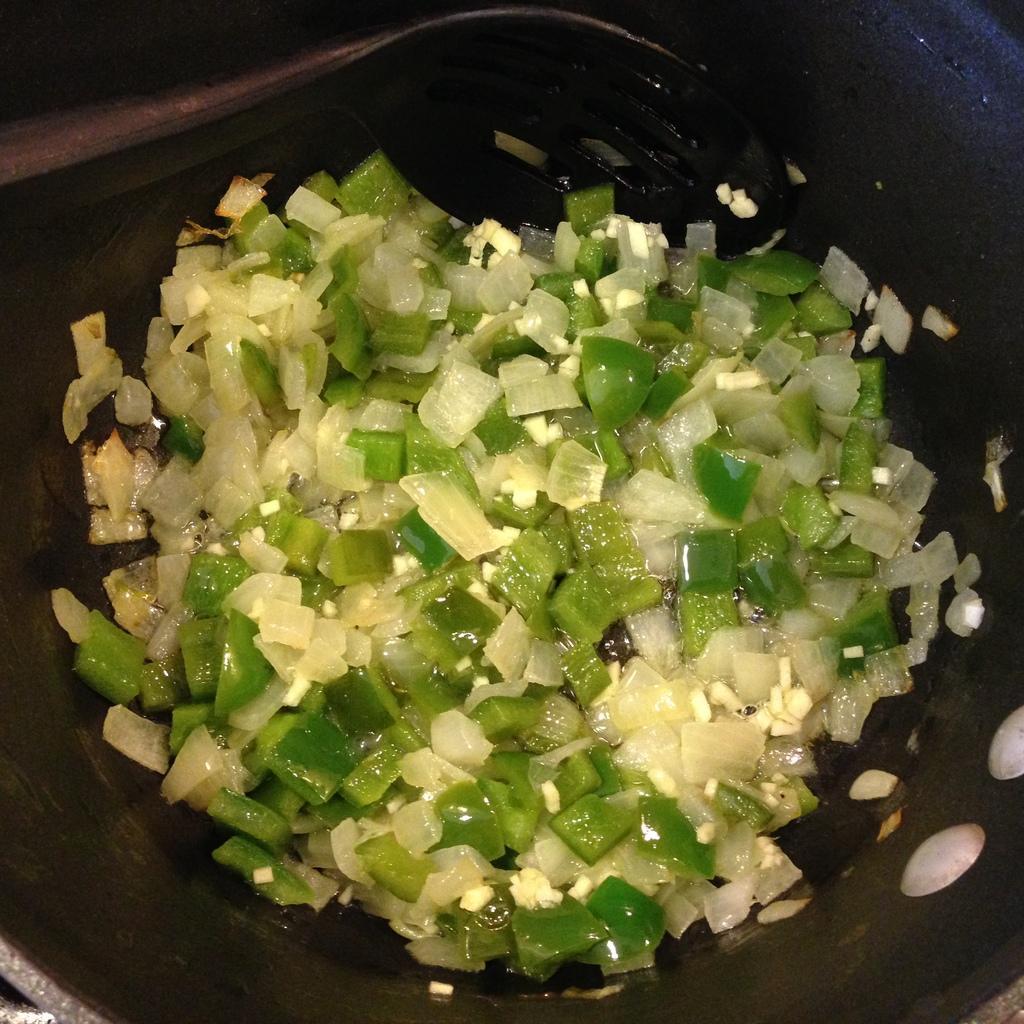How would you summarize this image in a sentence or two? In this image there are chopped onions and capsicum in a pan. 